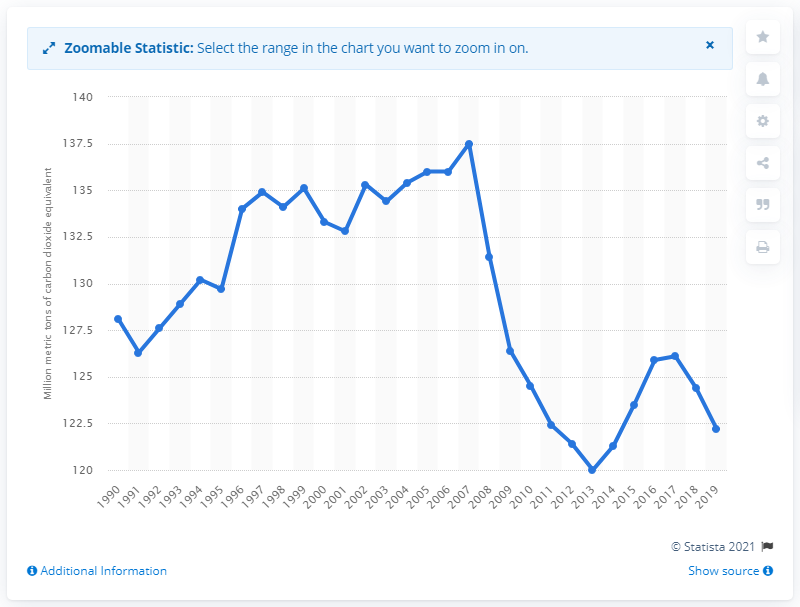Indicate a few pertinent items in this graphic. In the UK by 2018, the amount of carbon dioxide equivalent was 122.2. The transport sector has been the primary source of greenhouse gas emissions in the UK since 2016. By 2013, transport-related greenhouse gas (GHG) emissions had dropped to a historic low of 120 million metric tons of carbon dioxide equivalent. In 2000, the peak amount of carbon dioxide equivalent in the UK was 137.5. 